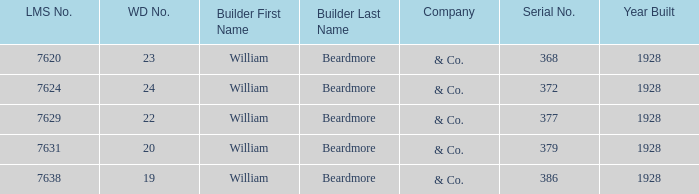Name the lms number for serial number being 372 7624.0. 